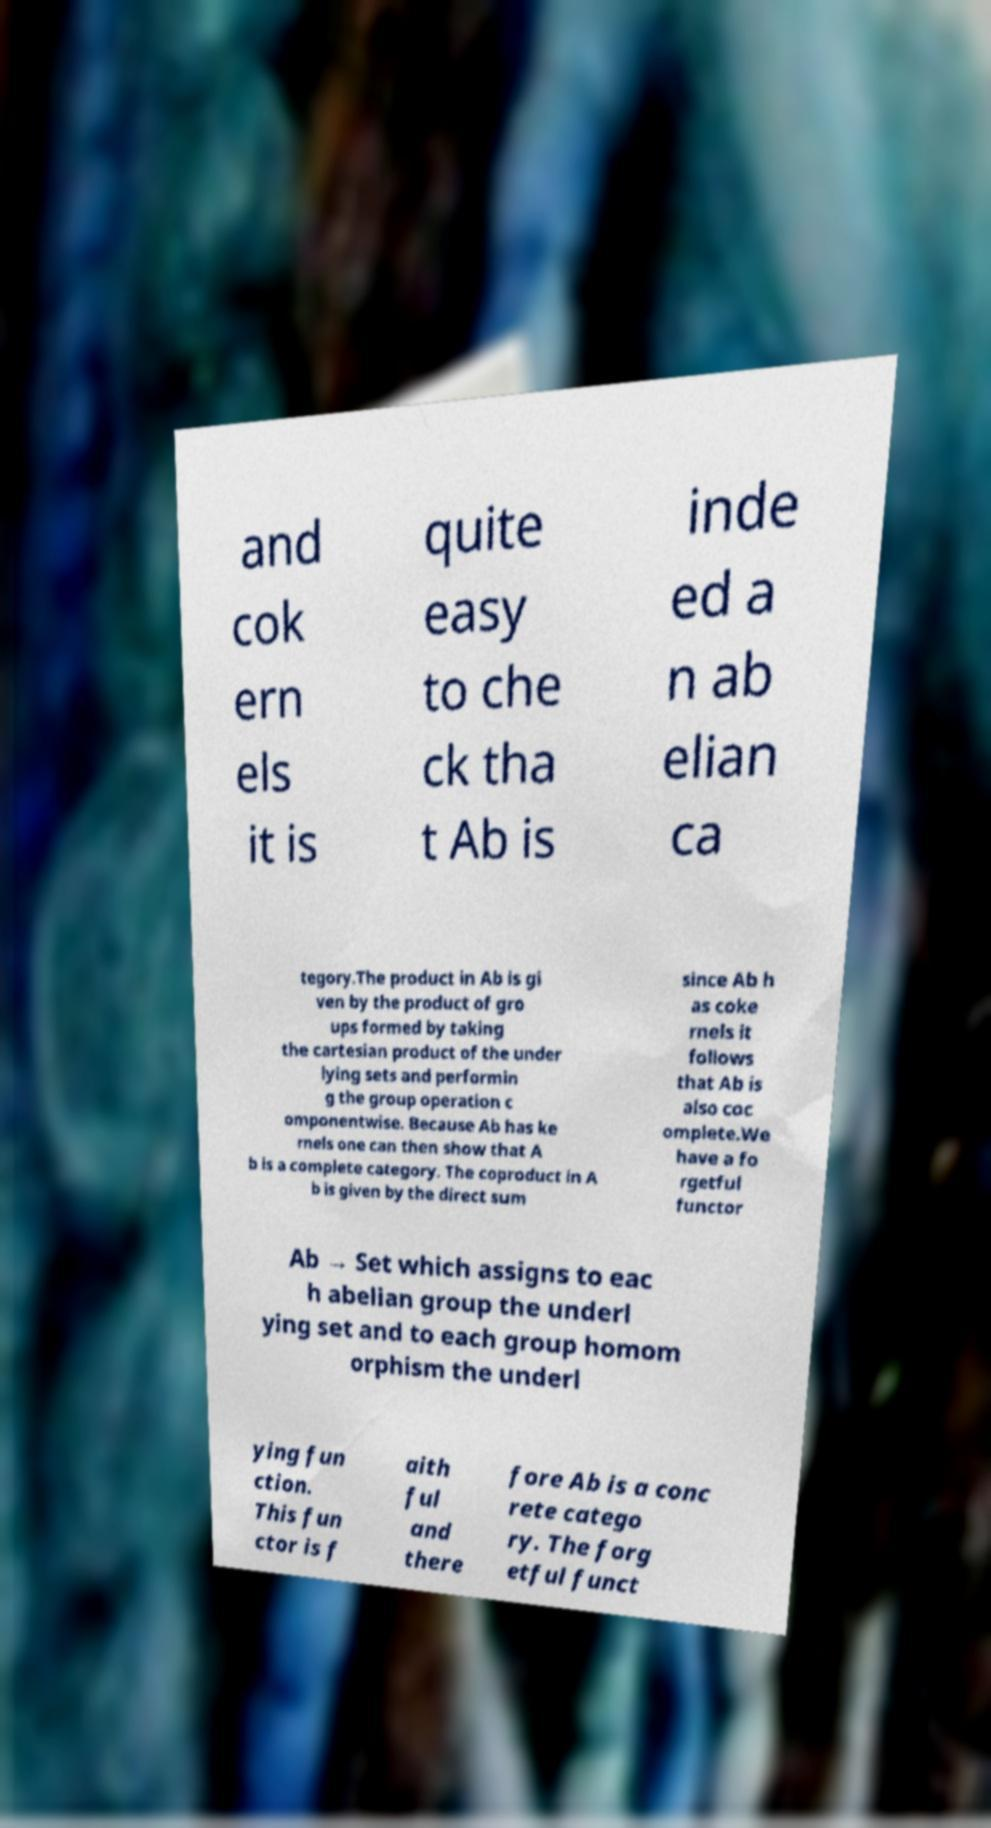Can you read and provide the text displayed in the image?This photo seems to have some interesting text. Can you extract and type it out for me? and cok ern els it is quite easy to che ck tha t Ab is inde ed a n ab elian ca tegory.The product in Ab is gi ven by the product of gro ups formed by taking the cartesian product of the under lying sets and performin g the group operation c omponentwise. Because Ab has ke rnels one can then show that A b is a complete category. The coproduct in A b is given by the direct sum since Ab h as coke rnels it follows that Ab is also coc omplete.We have a fo rgetful functor Ab → Set which assigns to eac h abelian group the underl ying set and to each group homom orphism the underl ying fun ction. This fun ctor is f aith ful and there fore Ab is a conc rete catego ry. The forg etful funct 